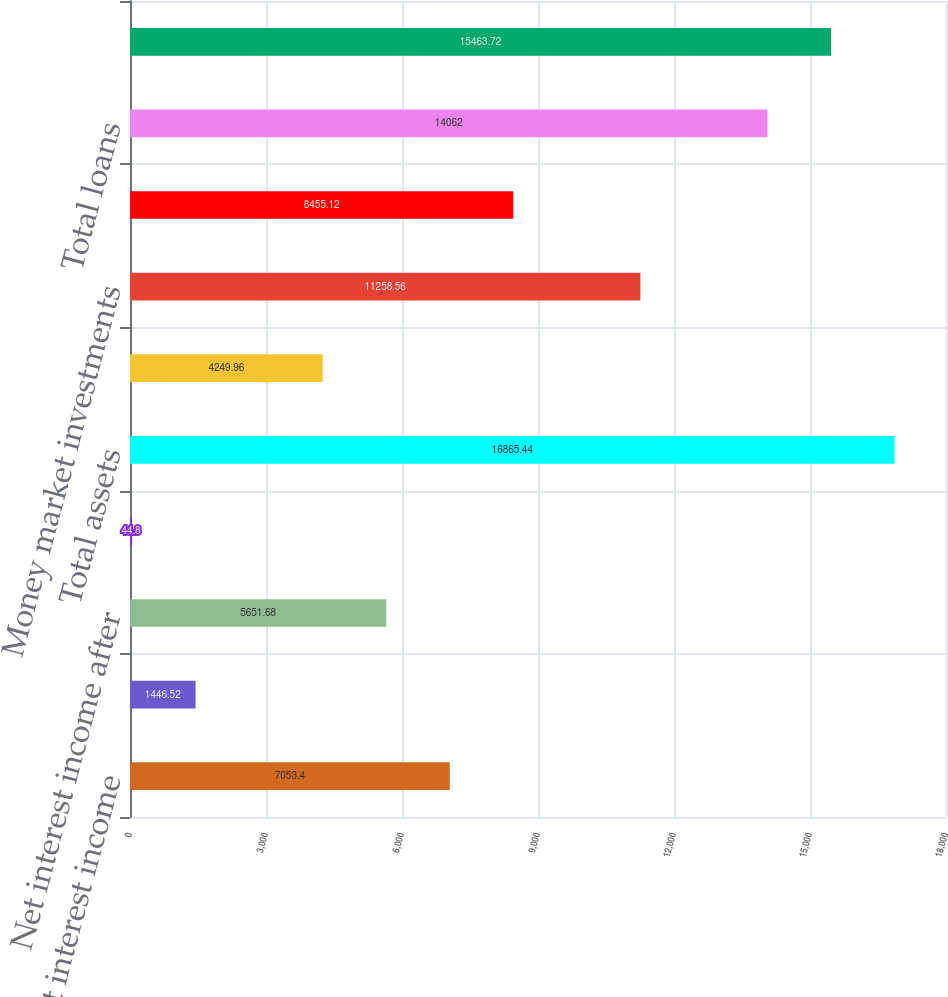<chart> <loc_0><loc_0><loc_500><loc_500><bar_chart><fcel>Net interest income<fcel>Provision for loan losses<fcel>Net interest income after<fcel>Net income (loss) applicable<fcel>Total assets<fcel>Cash and due from banks<fcel>Money market investments<fcel>Total securities<fcel>Total loans<fcel>Total deposits<nl><fcel>7053.4<fcel>1446.52<fcel>5651.68<fcel>44.8<fcel>16865.4<fcel>4249.96<fcel>11258.6<fcel>8455.12<fcel>14062<fcel>15463.7<nl></chart> 